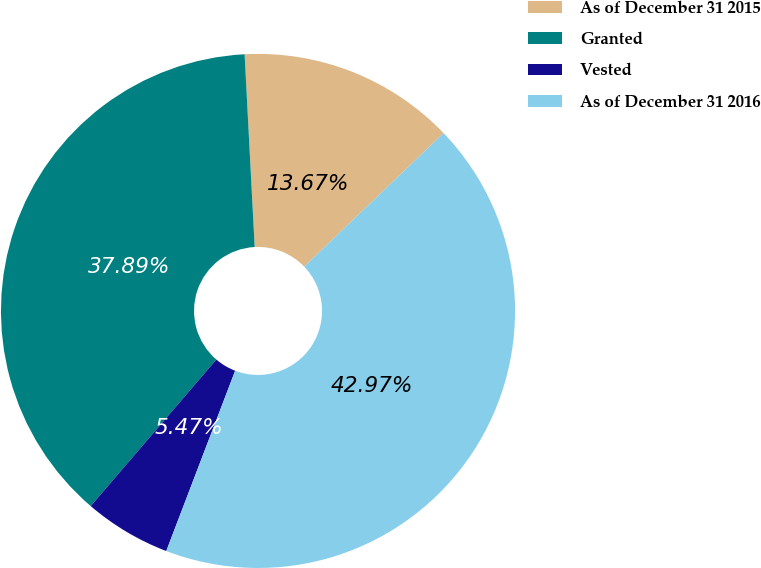Convert chart. <chart><loc_0><loc_0><loc_500><loc_500><pie_chart><fcel>As of December 31 2015<fcel>Granted<fcel>Vested<fcel>As of December 31 2016<nl><fcel>13.67%<fcel>37.89%<fcel>5.47%<fcel>42.97%<nl></chart> 